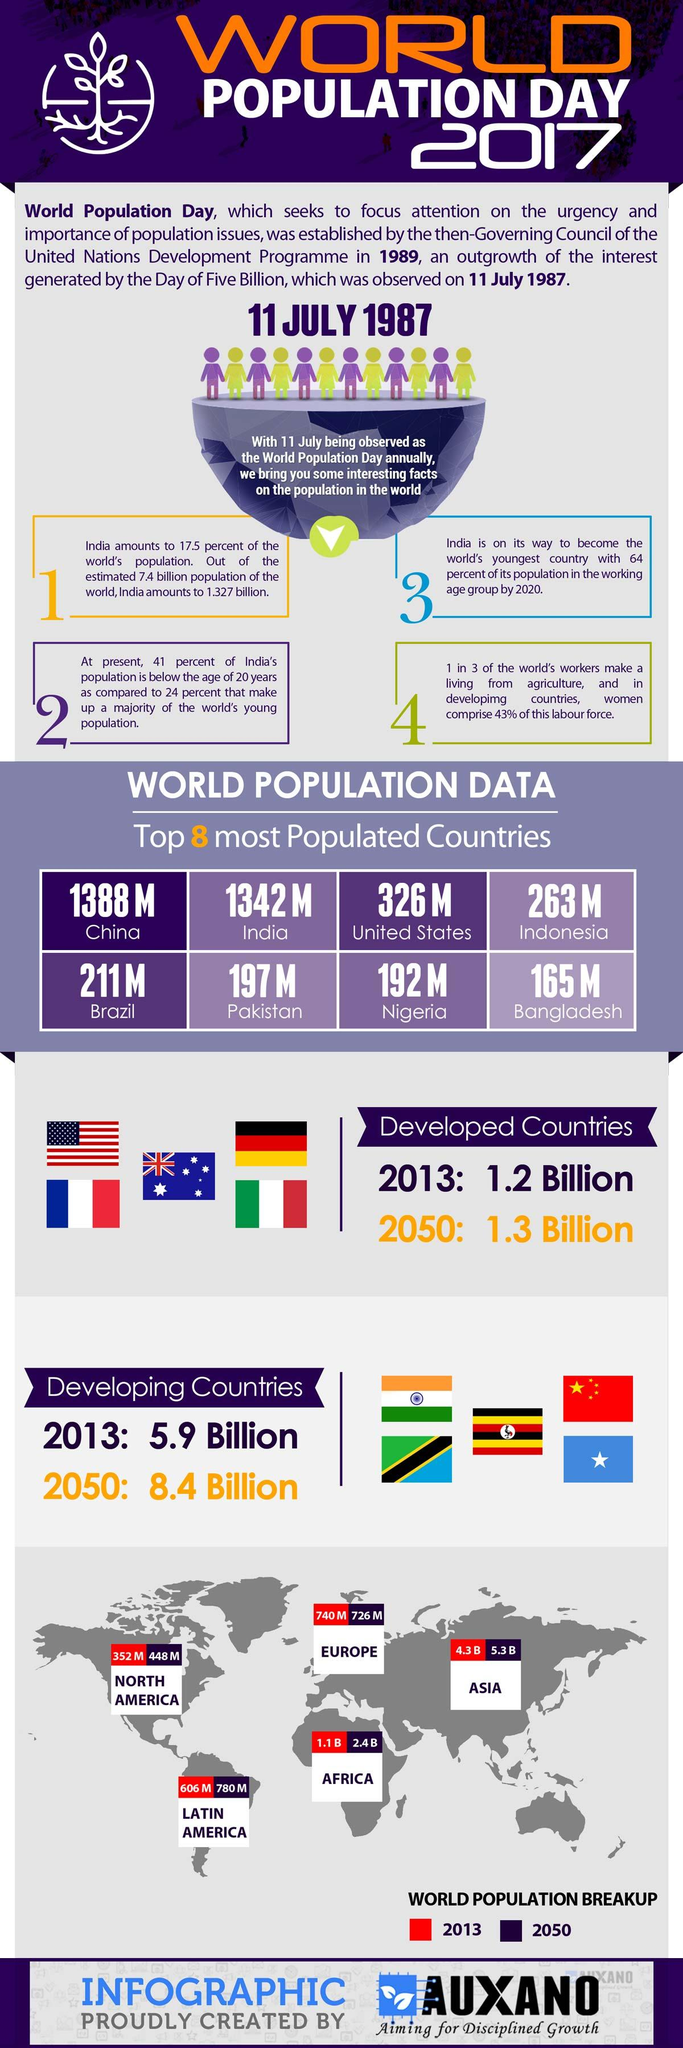Identify some key points in this picture. Five developed countries' flags are mentioned in this infographic. Five developing countries' flags are mentioned in this infographic. 